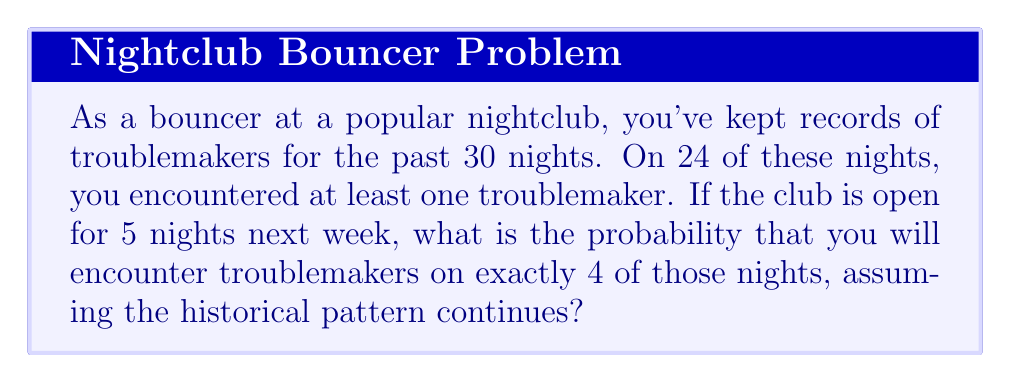Help me with this question. Let's approach this step-by-step using the binomial probability formula:

1) First, we need to calculate the probability of encountering troublemakers on a single night:
   $p = \frac{24}{30} = 0.8$ or 80%

2) The probability of not encountering troublemakers on a single night is:
   $q = 1 - p = 1 - 0.8 = 0.2$ or 20%

3) We want the probability of encountering troublemakers on exactly 4 out of 5 nights. This follows a binomial distribution.

4) The binomial probability formula is:
   $$P(X = k) = \binom{n}{k} p^k (1-p)^{n-k}$$
   where:
   $n$ is the number of trials (5 nights)
   $k$ is the number of successes (4 nights with troublemakers)
   $p$ is the probability of success on a single trial (0.8)

5) Plugging in our values:
   $$P(X = 4) = \binom{5}{4} (0.8)^4 (0.2)^1$$

6) Calculate the binomial coefficient:
   $$\binom{5}{4} = \frac{5!}{4!(5-4)!} = \frac{5!}{4!1!} = 5$$

7) Now we can compute:
   $$P(X = 4) = 5 \cdot (0.8)^4 \cdot (0.2)^1 = 5 \cdot 0.4096 \cdot 0.2 = 0.4096$$

8) Therefore, the probability is approximately 0.4096 or 40.96%
Answer: $0.4096$ or $40.96\%$ 